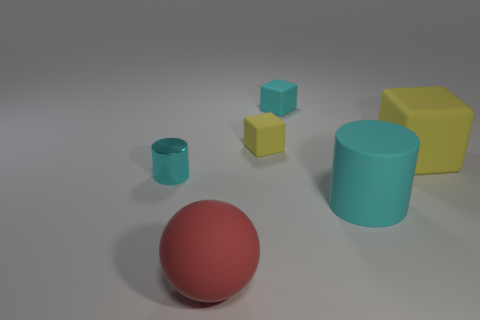There is a rubber block on the left side of the tiny cyan cube; is it the same size as the cyan object that is behind the shiny cylinder?
Ensure brevity in your answer.  Yes. Are there fewer small brown metal things than tiny cyan rubber things?
Provide a succinct answer. Yes. How many big red things are behind the large sphere?
Offer a terse response. 0. What is the large yellow thing made of?
Ensure brevity in your answer.  Rubber. Does the ball have the same color as the tiny metallic cylinder?
Keep it short and to the point. No. Is the number of large things in front of the big cyan object less than the number of small purple cylinders?
Your response must be concise. No. What color is the big thing that is behind the cyan metal cylinder?
Provide a succinct answer. Yellow. The small metal object has what shape?
Your response must be concise. Cylinder. There is a cyan matte thing to the left of the cyan cylinder that is right of the cyan cube; is there a tiny object that is behind it?
Make the answer very short. No. The thing left of the large object that is left of the cyan cylinder that is to the right of the small shiny cylinder is what color?
Offer a terse response. Cyan. 